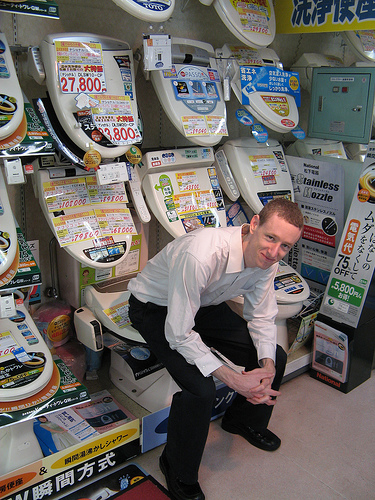What is the name of the articles of clothing that are black? The articles of clothing that are black are the trousers, which the boy is wearing. 